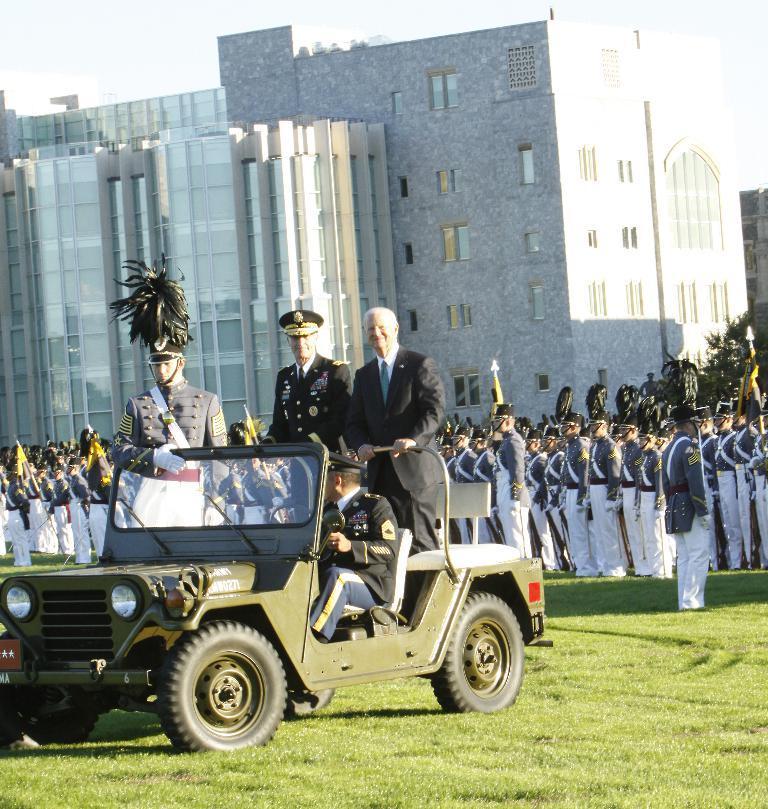Please provide a concise description of this image. In this picture I can observe a jeep. There are four members in the jeep. In the background I can observe some people standing on the ground and I can observe a building behind them. 